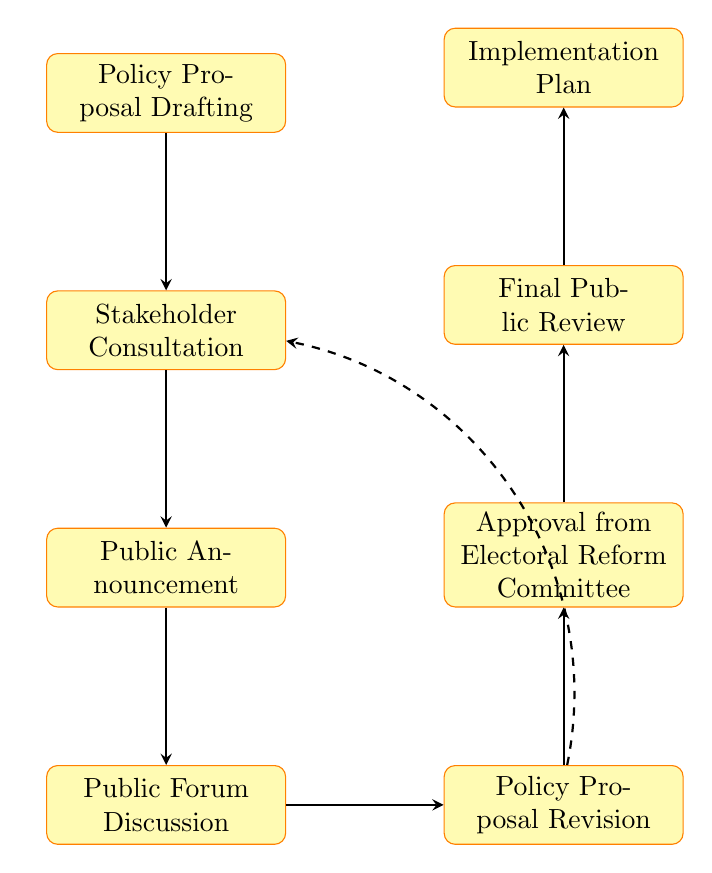What is the first node in the process? The first node in the process is indicated at the top of the flow chart, labeled as "Policy Proposal Drafting."
Answer: Policy Proposal Drafting What follows after Stakeholder Consultation? The flow chart indicates arrows showing the flow from one node to the next. After "Stakeholder Consultation," the next node is "Public Announcement."
Answer: Public Announcement How many nodes are in the diagram? By counting each distinct process in the flow chart, there are a total of eight nodes present, listed from "Policy Proposal Drafting" to "Implementation Plan."
Answer: Eight What is the last step in the approval process? The process is organized to show a clear pathway leading to the final node. The last step, located at the top of the flow, is labeled "Implementation Plan."
Answer: Implementation Plan Which nodes have arrows indicating feedback loops? The diagram shows a dashed arrow looping back from "Policy Proposal Revision" to "Stakeholder Consultation," indicating that feedback can go back to this stage for further refinement.
Answer: Stakeholder Consultation What is the purpose of the "Final Public Review" node? The flow chart suggests that "Final Public Review" is a key final step that allows for last-minute feedback and transparency before the policy implementation is finalized.
Answer: Last-minute feedback and transparency Which step comes directly before "Implementation Plan"? The arrows in the diagram lead directly from "Final Public Review" to "Implementation Plan," indicating that the former step occurs just before the latter.
Answer: Final Public Review What does the dashed arrow represent? The dashed arrow in the diagram depicts a feedback loop, signifying the process allows for a return to "Stakeholder Consultation" after "Policy Proposal Revision," indicating iterative changes based on stakeholders’ input.
Answer: Feedback loop 